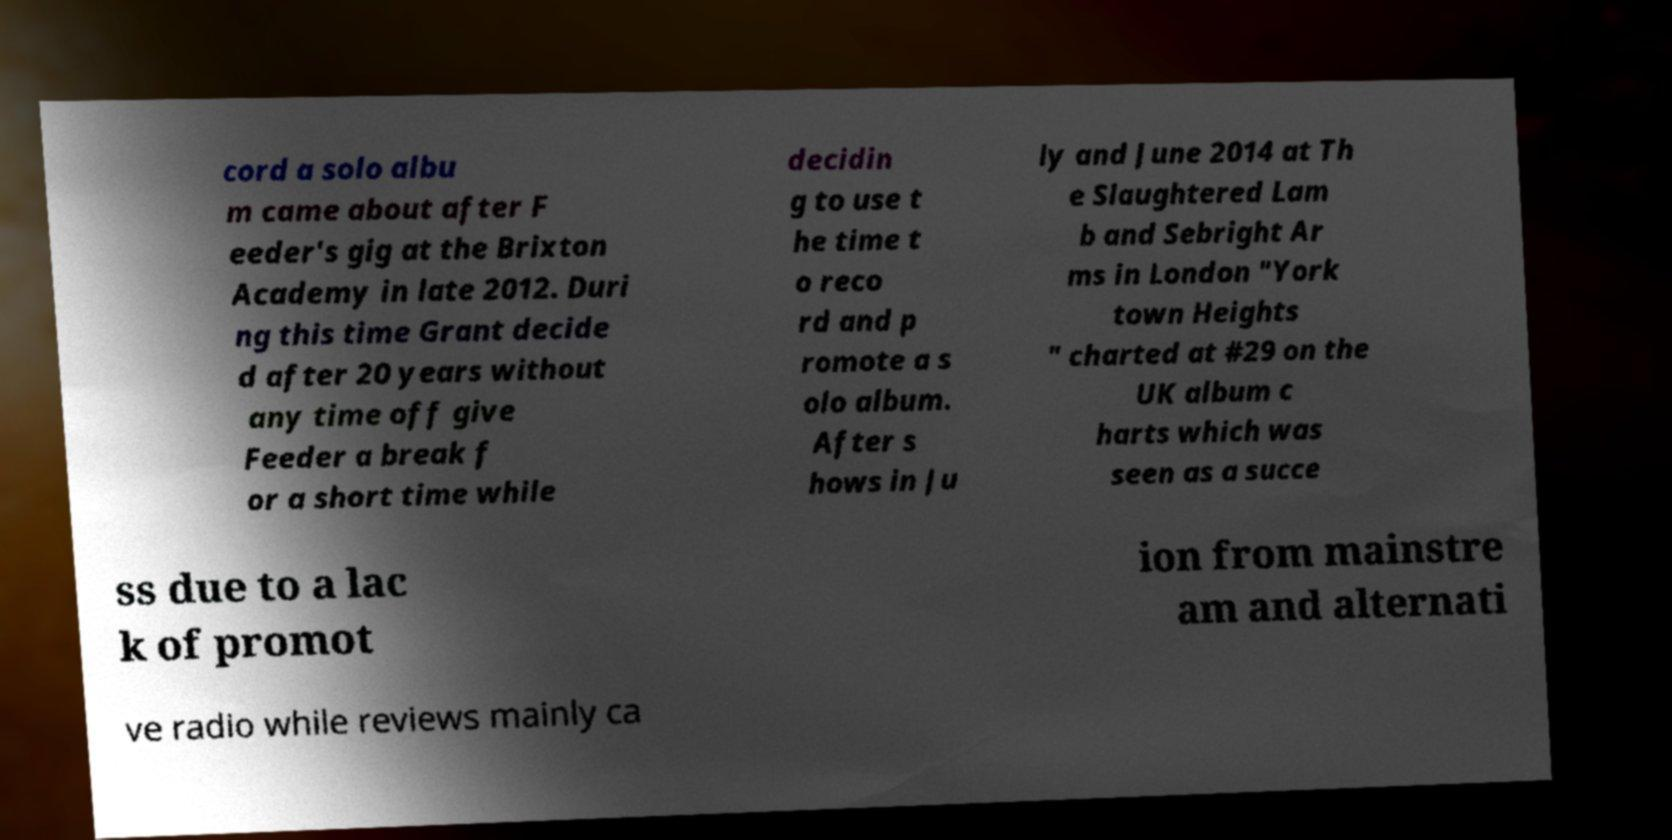Please identify and transcribe the text found in this image. cord a solo albu m came about after F eeder's gig at the Brixton Academy in late 2012. Duri ng this time Grant decide d after 20 years without any time off give Feeder a break f or a short time while decidin g to use t he time t o reco rd and p romote a s olo album. After s hows in Ju ly and June 2014 at Th e Slaughtered Lam b and Sebright Ar ms in London "York town Heights " charted at #29 on the UK album c harts which was seen as a succe ss due to a lac k of promot ion from mainstre am and alternati ve radio while reviews mainly ca 